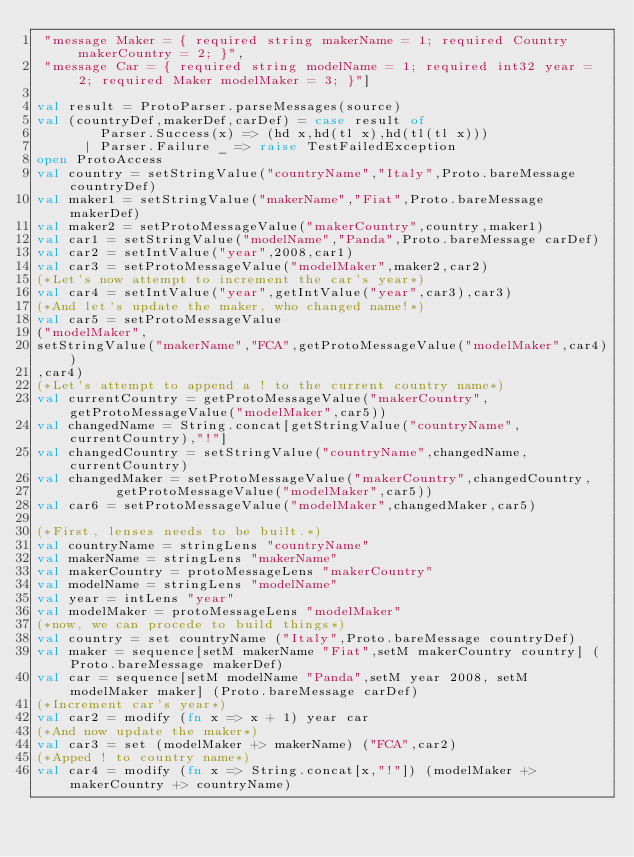Convert code to text. <code><loc_0><loc_0><loc_500><loc_500><_SML_> "message Maker = { required string makerName = 1; required Country makerCountry = 2; }",
 "message Car = { required string modelName = 1; required int32 year = 2; required Maker modelMaker = 3; }"]

val result = ProtoParser.parseMessages(source)
val (countryDef,makerDef,carDef) = case result of
				Parser.Success(x) => (hd x,hd(tl x),hd(tl(tl x)))
			|	Parser.Failure _ => raise TestFailedException
open ProtoAccess
val country = setStringValue("countryName","Italy",Proto.bareMessage countryDef)
val maker1 = setStringValue("makerName","Fiat",Proto.bareMessage makerDef)
val maker2 = setProtoMessageValue("makerCountry",country,maker1)
val car1 = setStringValue("modelName","Panda",Proto.bareMessage carDef)
val car2 = setIntValue("year",2008,car1)
val car3 = setProtoMessageValue("modelMaker",maker2,car2)
(*Let's now attempt to increment the car's year*)
val car4 = setIntValue("year",getIntValue("year",car3),car3)
(*And let's update the maker, who changed name!*)
val car5 = setProtoMessageValue
("modelMaker",
setStringValue("makerName","FCA",getProtoMessageValue("modelMaker",car4))
,car4)
(*Let's attempt to append a ! to the current country name*)
val currentCountry = getProtoMessageValue("makerCountry",getProtoMessageValue("modelMaker",car5))
val changedName = String.concat[getStringValue("countryName",currentCountry),"!"]
val changedCountry = setStringValue("countryName",changedName,currentCountry)
val changedMaker = setProtoMessageValue("makerCountry",changedCountry,
					getProtoMessageValue("modelMaker",car5))
val car6 = setProtoMessageValue("modelMaker",changedMaker,car5)

(*First, lenses needs to be built.*)
val countryName = stringLens "countryName"
val makerName = stringLens "makerName"
val makerCountry = protoMessageLens "makerCountry"
val modelName = stringLens "modelName"
val year = intLens "year"
val modelMaker = protoMessageLens "modelMaker"
(*now, we can procede to build things*)
val country = set countryName ("Italy",Proto.bareMessage countryDef)
val maker = sequence[setM makerName "Fiat",setM makerCountry country] (Proto.bareMessage makerDef)
val car = sequence[setM modelName "Panda",setM year 2008, setM modelMaker maker] (Proto.bareMessage carDef)
(*Increment car's year*)
val car2 = modify (fn x => x + 1) year car
(*And now update the maker*)
val car3 = set (modelMaker +> makerName) ("FCA",car2)
(*Apped ! to country name*)
val car4 = modify (fn x => String.concat[x,"!"]) (modelMaker +> makerCountry +> countryName) </code> 